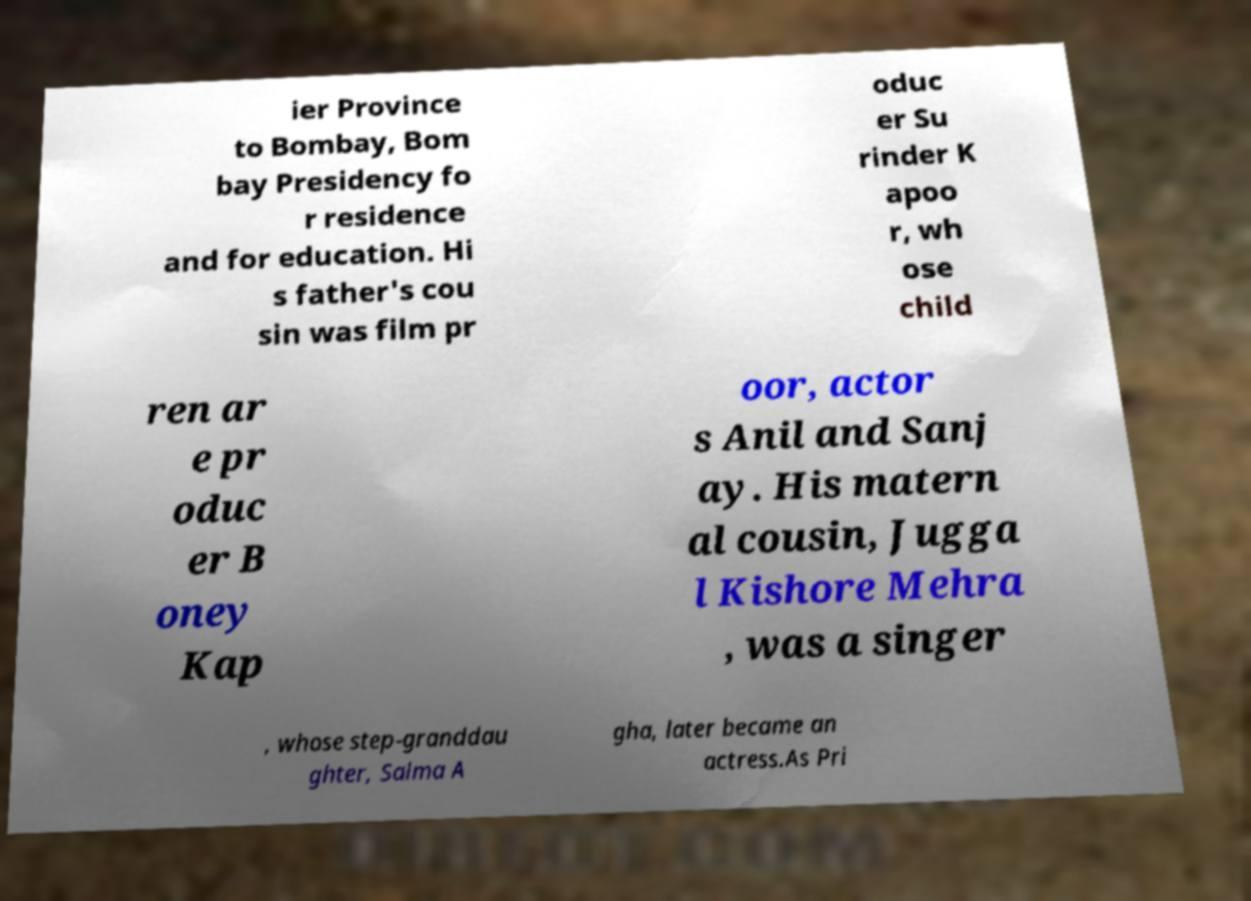Please identify and transcribe the text found in this image. ier Province to Bombay, Bom bay Presidency fo r residence and for education. Hi s father's cou sin was film pr oduc er Su rinder K apoo r, wh ose child ren ar e pr oduc er B oney Kap oor, actor s Anil and Sanj ay. His matern al cousin, Jugga l Kishore Mehra , was a singer , whose step-granddau ghter, Salma A gha, later became an actress.As Pri 